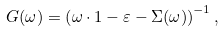Convert formula to latex. <formula><loc_0><loc_0><loc_500><loc_500>G ( \omega ) = \left ( \omega \cdot 1 - \varepsilon - \Sigma ( \omega ) \right ) ^ { - 1 } ,</formula> 